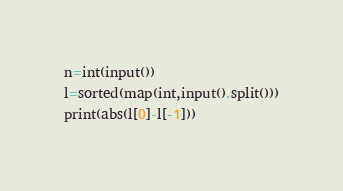Convert code to text. <code><loc_0><loc_0><loc_500><loc_500><_Python_>n=int(input())
l=sorted(map(int,input().split()))
print(abs(l[0]-l[-1]))

</code> 